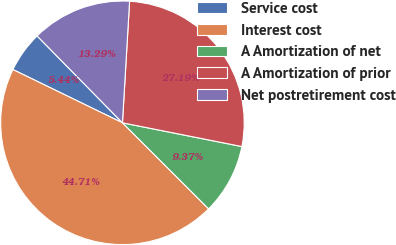Convert chart to OTSL. <chart><loc_0><loc_0><loc_500><loc_500><pie_chart><fcel>Service cost<fcel>Interest cost<fcel>A Amortization of net<fcel>A Amortization of prior<fcel>Net postretirement cost<nl><fcel>5.44%<fcel>44.71%<fcel>9.37%<fcel>27.19%<fcel>13.29%<nl></chart> 